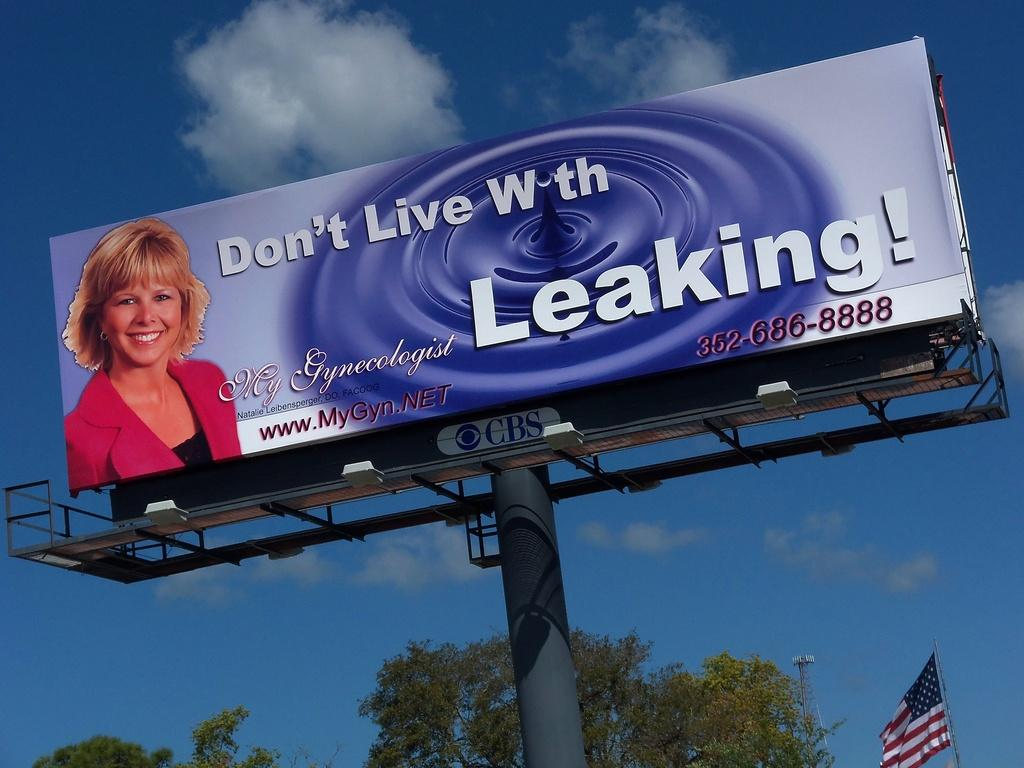<image>
Give a short and clear explanation of the subsequent image. A sign with a blond lady advertising a gynecologist 